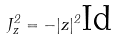<formula> <loc_0><loc_0><loc_500><loc_500>J _ { z } ^ { 2 } = - | z | ^ { 2 } \text {Id}</formula> 